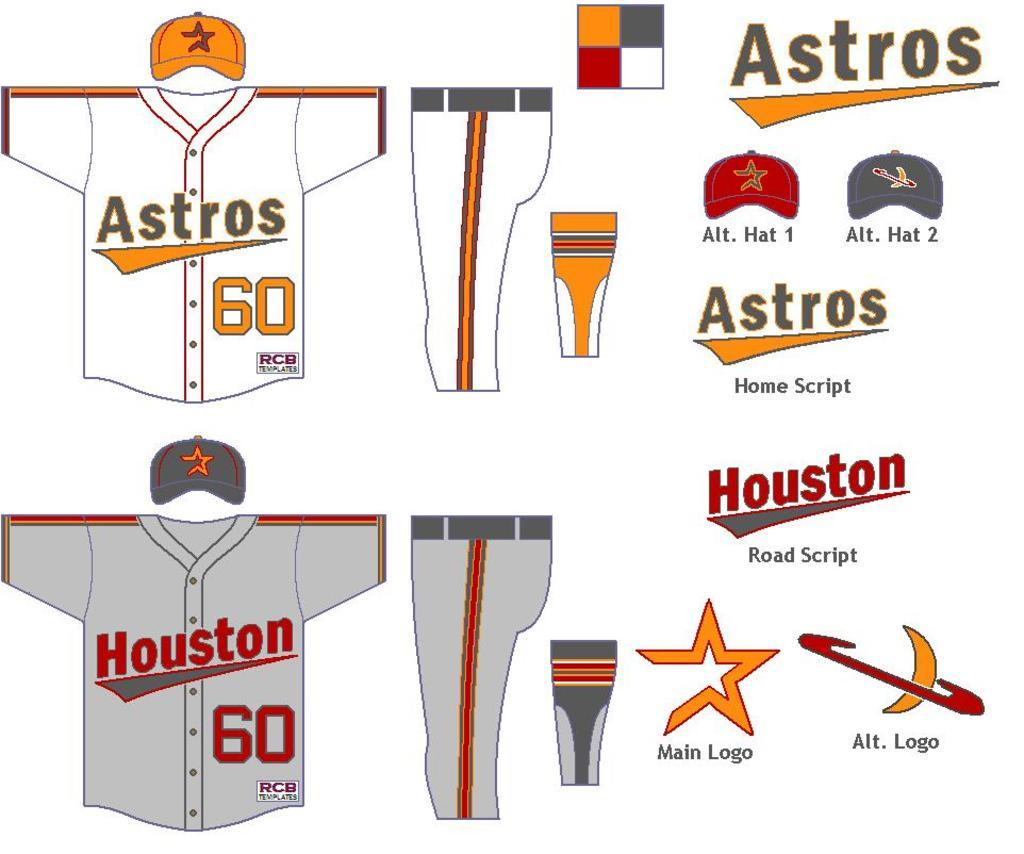<image>
Offer a succinct explanation of the picture presented. A graphic showing the design of the Huston Astros uniforms. 